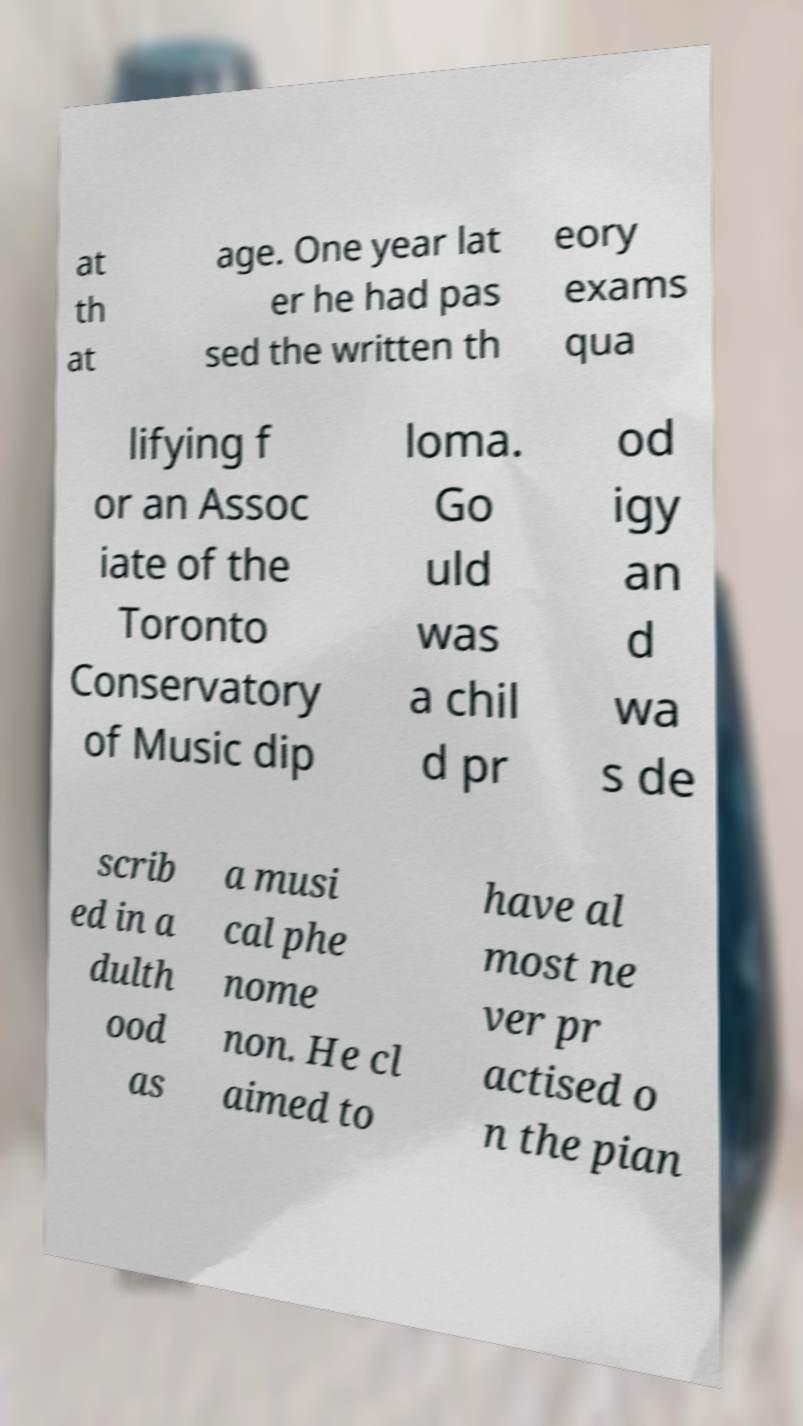Can you accurately transcribe the text from the provided image for me? at th at age. One year lat er he had pas sed the written th eory exams qua lifying f or an Assoc iate of the Toronto Conservatory of Music dip loma. Go uld was a chil d pr od igy an d wa s de scrib ed in a dulth ood as a musi cal phe nome non. He cl aimed to have al most ne ver pr actised o n the pian 